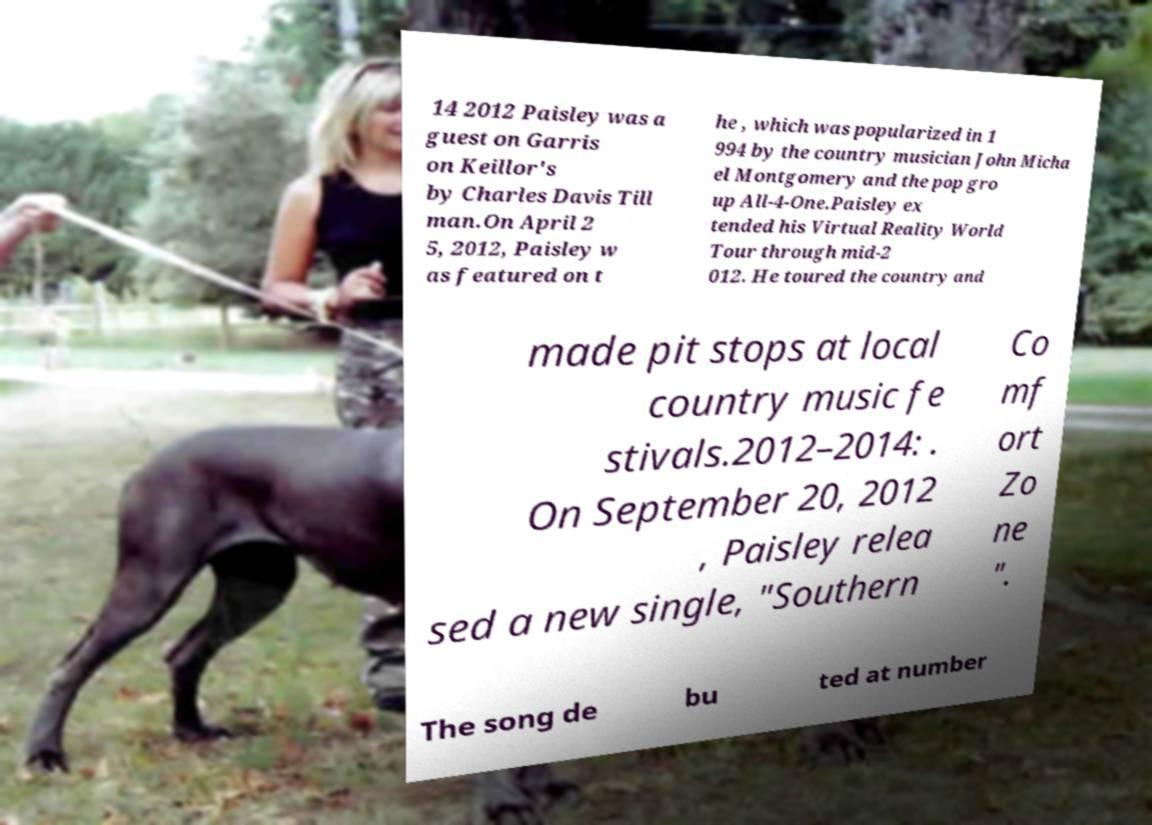Could you assist in decoding the text presented in this image and type it out clearly? 14 2012 Paisley was a guest on Garris on Keillor's by Charles Davis Till man.On April 2 5, 2012, Paisley w as featured on t he , which was popularized in 1 994 by the country musician John Micha el Montgomery and the pop gro up All-4-One.Paisley ex tended his Virtual Reality World Tour through mid-2 012. He toured the country and made pit stops at local country music fe stivals.2012–2014: . On September 20, 2012 , Paisley relea sed a new single, "Southern Co mf ort Zo ne ". The song de bu ted at number 